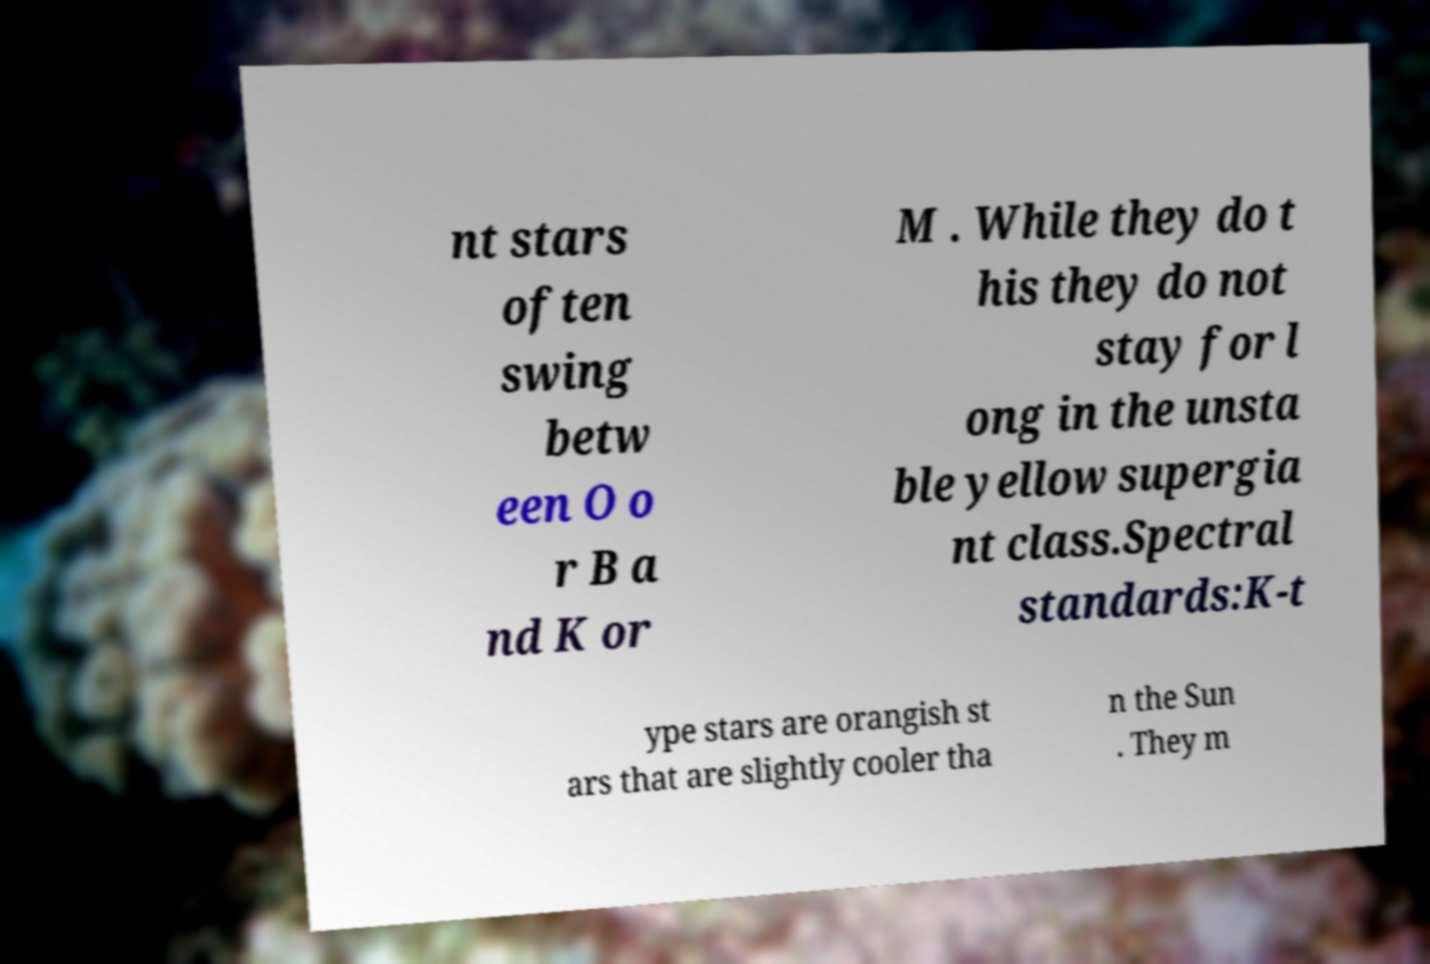What messages or text are displayed in this image? I need them in a readable, typed format. nt stars often swing betw een O o r B a nd K or M . While they do t his they do not stay for l ong in the unsta ble yellow supergia nt class.Spectral standards:K-t ype stars are orangish st ars that are slightly cooler tha n the Sun . They m 